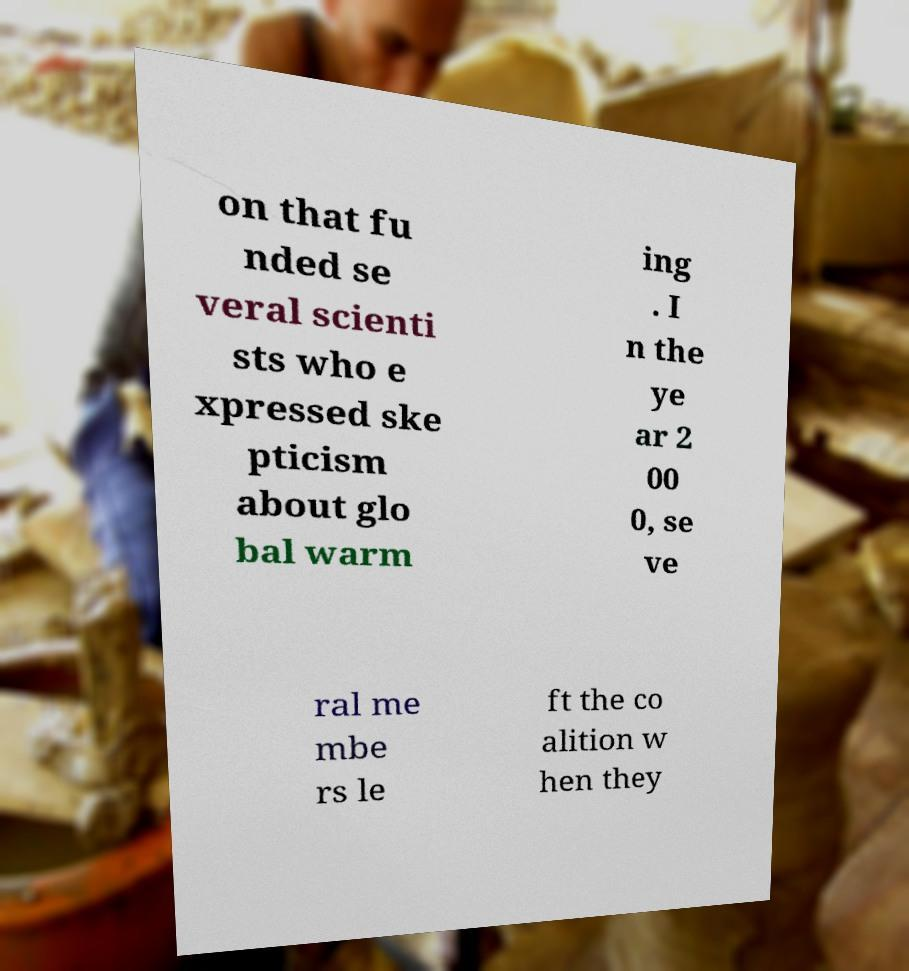What messages or text are displayed in this image? I need them in a readable, typed format. on that fu nded se veral scienti sts who e xpressed ske pticism about glo bal warm ing . I n the ye ar 2 00 0, se ve ral me mbe rs le ft the co alition w hen they 